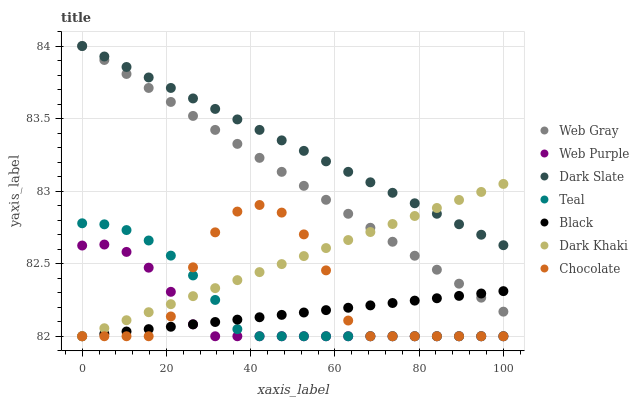Does Web Purple have the minimum area under the curve?
Answer yes or no. Yes. Does Dark Slate have the maximum area under the curve?
Answer yes or no. Yes. Does Chocolate have the minimum area under the curve?
Answer yes or no. No. Does Chocolate have the maximum area under the curve?
Answer yes or no. No. Is Dark Slate the smoothest?
Answer yes or no. Yes. Is Chocolate the roughest?
Answer yes or no. Yes. Is Dark Khaki the smoothest?
Answer yes or no. No. Is Dark Khaki the roughest?
Answer yes or no. No. Does Chocolate have the lowest value?
Answer yes or no. Yes. Does Dark Slate have the lowest value?
Answer yes or no. No. Does Dark Slate have the highest value?
Answer yes or no. Yes. Does Chocolate have the highest value?
Answer yes or no. No. Is Teal less than Dark Slate?
Answer yes or no. Yes. Is Dark Slate greater than Web Purple?
Answer yes or no. Yes. Does Web Purple intersect Black?
Answer yes or no. Yes. Is Web Purple less than Black?
Answer yes or no. No. Is Web Purple greater than Black?
Answer yes or no. No. Does Teal intersect Dark Slate?
Answer yes or no. No. 